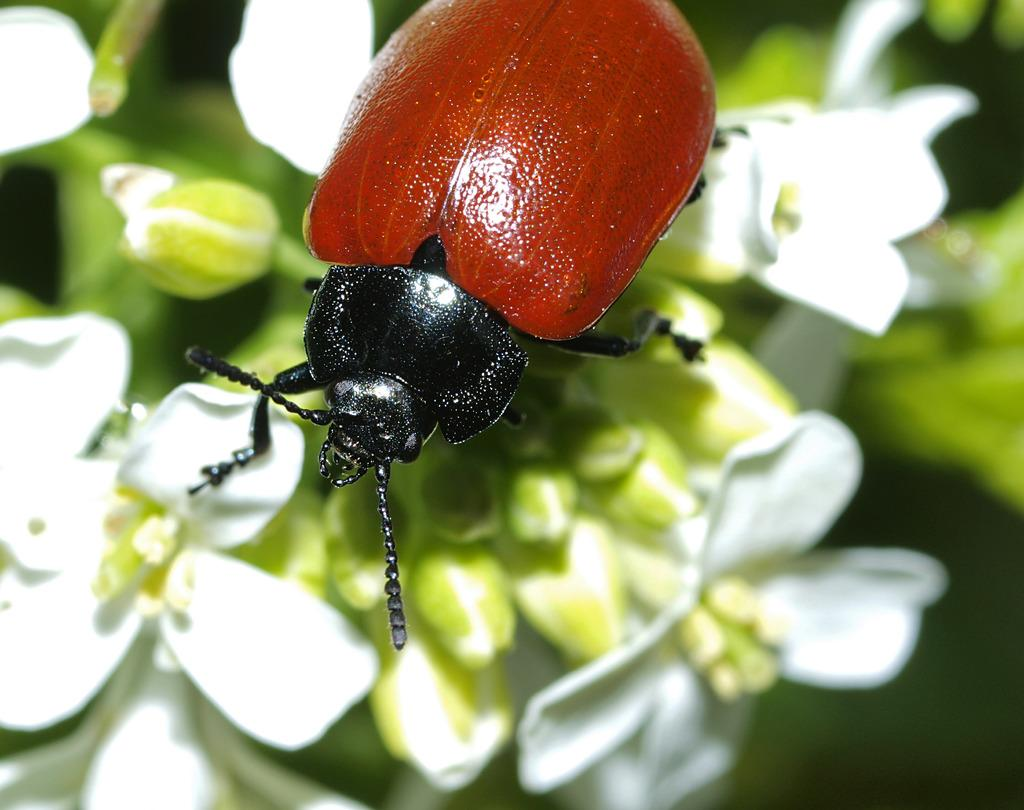What is the main subject of the picture? There is a beetle in the picture. How would you describe the background of the picture? The background is blurred. What type of vegetation can be seen in the background of the picture? There are flowers and leaves in the background of the picture. How many tails does the beetle have in the picture? Beetles typically have one pair of wings that are hardened into wing cases, which might be mistaken for tails. However, in this context, the beetle does not have a tail. What emotion does the beetle convey in the picture? Insects do not convey emotions in the same way as humans or animals, so it is not possible to determine the emotion the beetle conveys in the picture. 